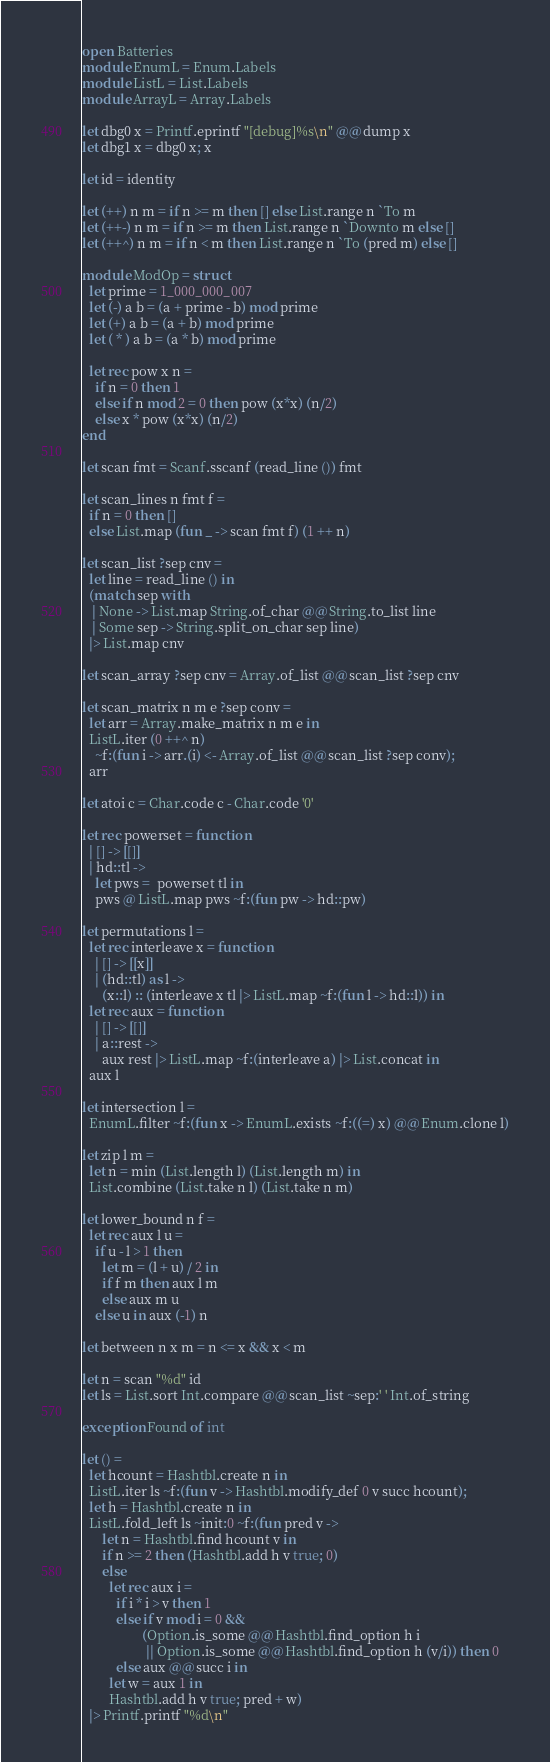<code> <loc_0><loc_0><loc_500><loc_500><_OCaml_>open Batteries
module EnumL = Enum.Labels
module ListL = List.Labels
module ArrayL = Array.Labels

let dbg0 x = Printf.eprintf "[debug]%s\n" @@ dump x
let dbg1 x = dbg0 x; x

let id = identity

let (++) n m = if n >= m then [] else List.range n `To m
let (++-) n m = if n >= m then List.range n `Downto m else []
let (++^) n m = if n < m then List.range n `To (pred m) else []

module ModOp = struct
  let prime = 1_000_000_007
  let (-) a b = (a + prime - b) mod prime
  let (+) a b = (a + b) mod prime
  let ( * ) a b = (a * b) mod prime

  let rec pow x n =
    if n = 0 then 1
    else if n mod 2 = 0 then pow (x*x) (n/2)
    else x * pow (x*x) (n/2)
end

let scan fmt = Scanf.sscanf (read_line ()) fmt

let scan_lines n fmt f =
  if n = 0 then []
  else List.map (fun _ -> scan fmt f) (1 ++ n)

let scan_list ?sep cnv =
  let line = read_line () in
  (match sep with
   | None -> List.map String.of_char @@ String.to_list line
   | Some sep -> String.split_on_char sep line)
  |> List.map cnv

let scan_array ?sep cnv = Array.of_list @@ scan_list ?sep cnv

let scan_matrix n m e ?sep conv =
  let arr = Array.make_matrix n m e in
  ListL.iter (0 ++^ n)
    ~f:(fun i -> arr.(i) <- Array.of_list @@ scan_list ?sep conv);
  arr

let atoi c = Char.code c - Char.code '0'

let rec powerset = function
  | [] -> [[]]
  | hd::tl ->
    let pws =  powerset tl in
    pws @ ListL.map pws ~f:(fun pw -> hd::pw)

let permutations l =
  let rec interleave x = function
    | [] -> [[x]]
    | (hd::tl) as l ->
      (x::l) :: (interleave x tl |> ListL.map ~f:(fun l -> hd::l)) in
  let rec aux = function
    | [] -> [[]]
    | a::rest ->
      aux rest |> ListL.map ~f:(interleave a) |> List.concat in
  aux l

let intersection l =
  EnumL.filter ~f:(fun x -> EnumL.exists ~f:((=) x) @@ Enum.clone l)

let zip l m =
  let n = min (List.length l) (List.length m) in
  List.combine (List.take n l) (List.take n m)

let lower_bound n f =
  let rec aux l u =
    if u - l > 1 then
      let m = (l + u) / 2 in
      if f m then aux l m
      else aux m u
    else u in aux (-1) n

let between n x m = n <= x && x < m

let n = scan "%d" id
let ls = List.sort Int.compare @@ scan_list ~sep:' ' Int.of_string

exception Found of int

let () =
  let hcount = Hashtbl.create n in
  ListL.iter ls ~f:(fun v -> Hashtbl.modify_def 0 v succ hcount);
  let h = Hashtbl.create n in
  ListL.fold_left ls ~init:0 ~f:(fun pred v ->
      let n = Hashtbl.find hcount v in
      if n >= 2 then (Hashtbl.add h v true; 0)
      else
        let rec aux i =
          if i * i > v then 1
          else if v mod i = 0 &&
                  (Option.is_some @@ Hashtbl.find_option h i
                   || Option.is_some @@ Hashtbl.find_option h (v/i)) then 0
          else aux @@ succ i in
        let w = aux 1 in
        Hashtbl.add h v true; pred + w)
  |> Printf.printf "%d\n"
</code> 